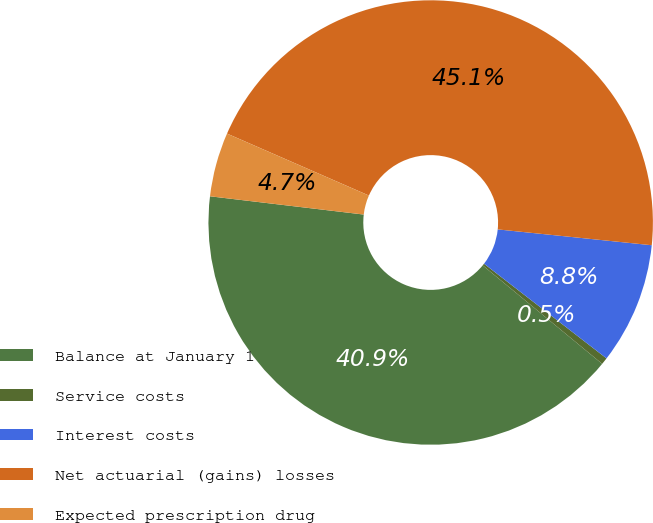Convert chart to OTSL. <chart><loc_0><loc_0><loc_500><loc_500><pie_chart><fcel>Balance at January 1<fcel>Service costs<fcel>Interest costs<fcel>Net actuarial (gains) losses<fcel>Expected prescription drug<nl><fcel>40.91%<fcel>0.5%<fcel>8.84%<fcel>45.08%<fcel>4.67%<nl></chart> 